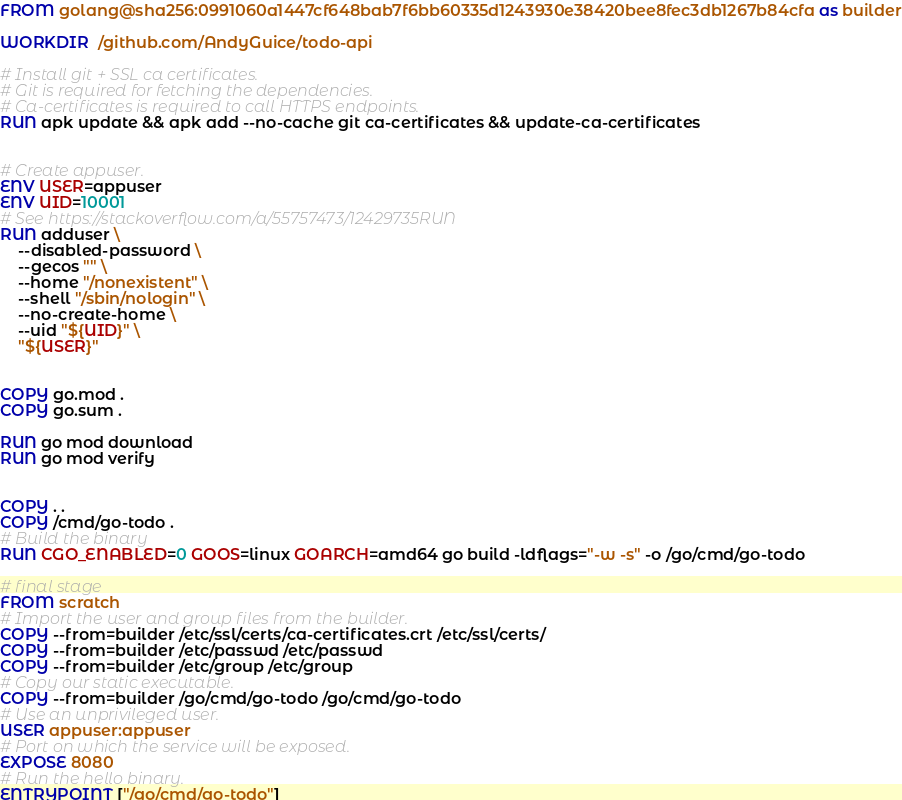Convert code to text. <code><loc_0><loc_0><loc_500><loc_500><_Dockerfile_>FROM golang@sha256:0991060a1447cf648bab7f6bb60335d1243930e38420bee8fec3db1267b84cfa as builder

WORKDIR  /github.com/AndyGuice/todo-api

# Install git + SSL ca certificates.
# Git is required for fetching the dependencies.
# Ca-certificates is required to call HTTPS endpoints.
RUN apk update && apk add --no-cache git ca-certificates && update-ca-certificates


# Create appuser.
ENV USER=appuser
ENV UID=10001
# See https://stackoverflow.com/a/55757473/12429735RUN
RUN adduser \
    --disabled-password \
    --gecos "" \
    --home "/nonexistent" \
    --shell "/sbin/nologin" \
    --no-create-home \
    --uid "${UID}" \
    "${USER}"


COPY go.mod .
COPY go.sum .

RUN go mod download
RUN go mod verify


COPY . .
COPY /cmd/go-todo .
# Build the binary
RUN CGO_ENABLED=0 GOOS=linux GOARCH=amd64 go build -ldflags="-w -s" -o /go/cmd/go-todo

# final stage
FROM scratch
# Import the user and group files from the builder.
COPY --from=builder /etc/ssl/certs/ca-certificates.crt /etc/ssl/certs/
COPY --from=builder /etc/passwd /etc/passwd
COPY --from=builder /etc/group /etc/group
# Copy our static executable.
COPY --from=builder /go/cmd/go-todo /go/cmd/go-todo
# Use an unprivileged user.
USER appuser:appuser
# Port on which the service will be exposed.
EXPOSE 8080
# Run the hello binary.
ENTRYPOINT ["/go/cmd/go-todo"]</code> 